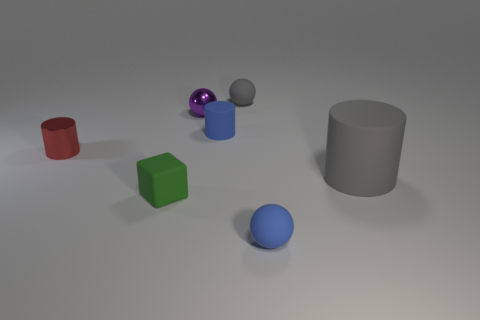Add 1 red shiny objects. How many objects exist? 8 Subtract all gray matte spheres. How many spheres are left? 2 Subtract 1 cubes. How many cubes are left? 0 Subtract all gray cylinders. How many cylinders are left? 2 Subtract all metal things. Subtract all matte cubes. How many objects are left? 4 Add 4 purple shiny things. How many purple shiny things are left? 5 Add 7 blue rubber spheres. How many blue rubber spheres exist? 8 Subtract 0 purple cylinders. How many objects are left? 7 Subtract all spheres. How many objects are left? 4 Subtract all blue spheres. Subtract all red cylinders. How many spheres are left? 2 